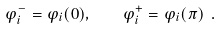<formula> <loc_0><loc_0><loc_500><loc_500>\varphi _ { i } ^ { - } = \varphi _ { i } ( 0 ) , \quad \varphi _ { i } ^ { + } = \varphi _ { i } ( \pi ) \ .</formula> 